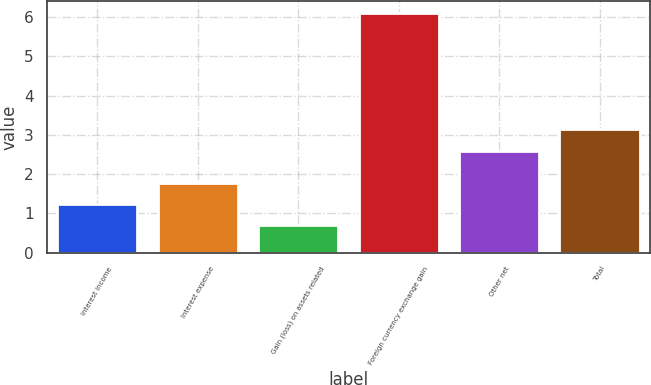Convert chart to OTSL. <chart><loc_0><loc_0><loc_500><loc_500><bar_chart><fcel>Interest income<fcel>Interest expense<fcel>Gain (loss) on assets related<fcel>Foreign currency exchange gain<fcel>Other net<fcel>Total<nl><fcel>1.24<fcel>1.78<fcel>0.7<fcel>6.1<fcel>2.6<fcel>3.14<nl></chart> 